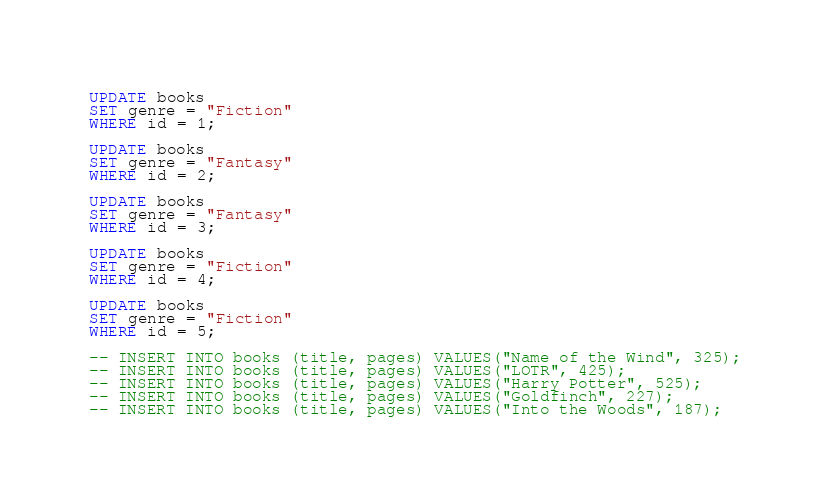Convert code to text. <code><loc_0><loc_0><loc_500><loc_500><_SQL_>UPDATE books
SET genre = "Fiction"
WHERE id = 1;

UPDATE books
SET genre = "Fantasy"
WHERE id = 2;

UPDATE books
SET genre = "Fantasy"
WHERE id = 3;

UPDATE books
SET genre = "Fiction"
WHERE id = 4;

UPDATE books
SET genre = "Fiction"
WHERE id = 5;

-- INSERT INTO books (title, pages) VALUES("Name of the Wind", 325);
-- INSERT INTO books (title, pages) VALUES("LOTR", 425);
-- INSERT INTO books (title, pages) VALUES("Harry Potter", 525);
-- INSERT INTO books (title, pages) VALUES("Goldfinch", 227);
-- INSERT INTO books (title, pages) VALUES("Into the Woods", 187);

</code> 